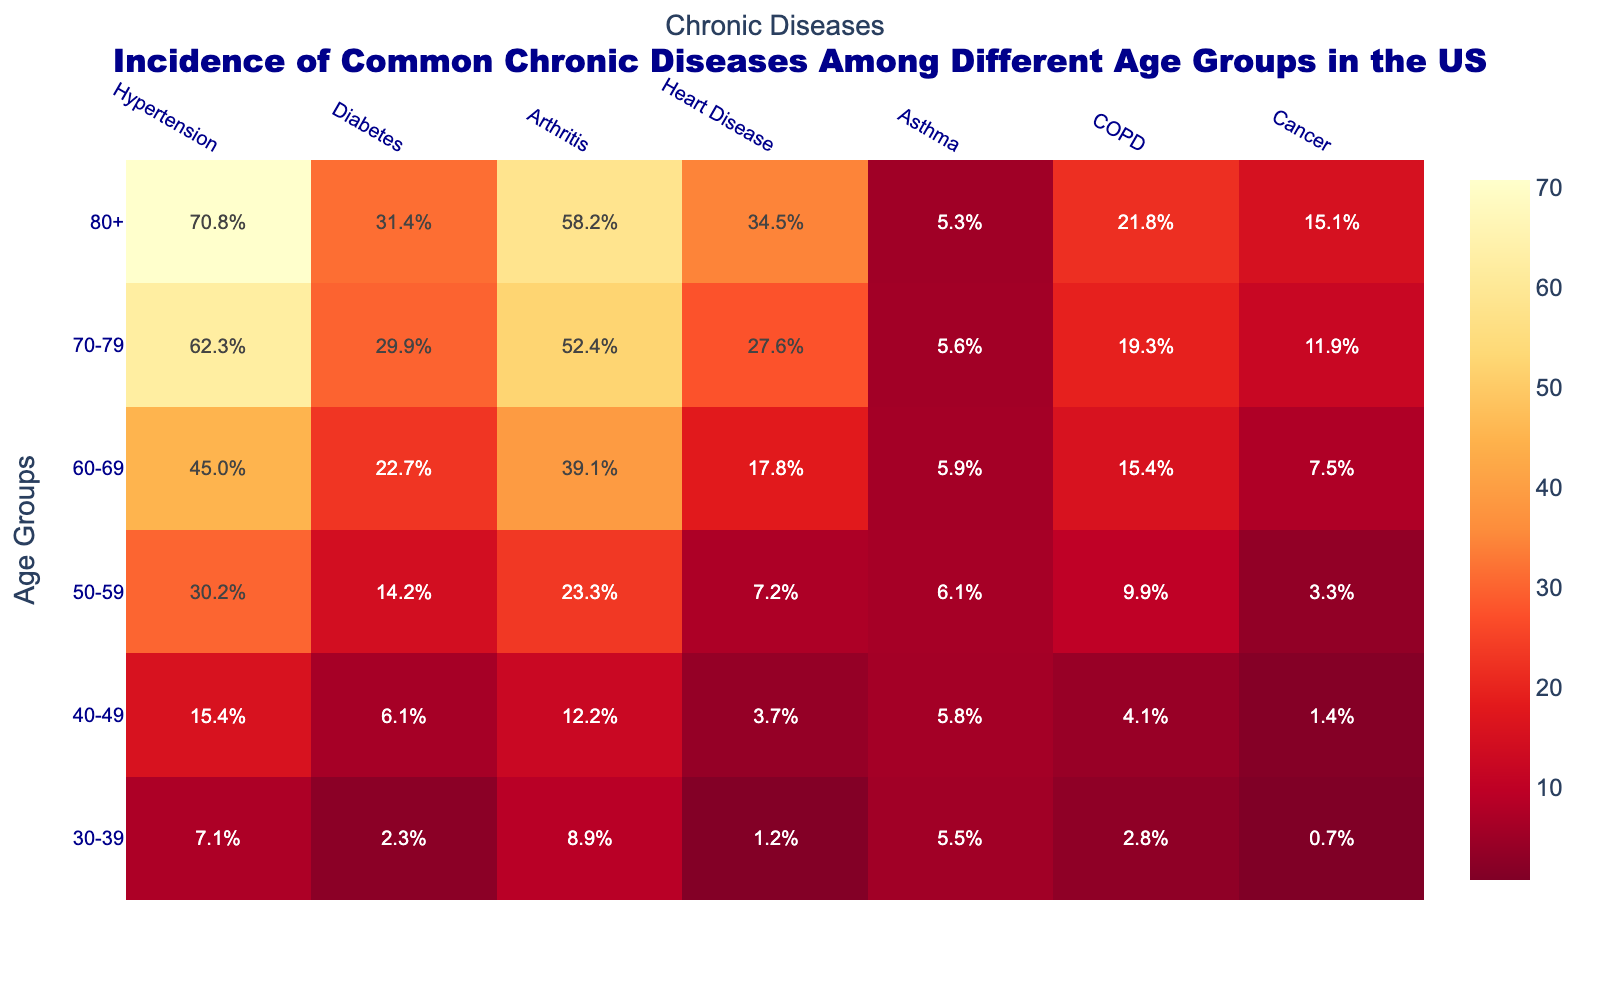What's the title of the figure? The title is prominently displayed at the top center of the figure. It reads: "Incidence of Common Chronic Diseases Among Different Age Groups in the US".
Answer: Incidence of Common Chronic Diseases Among Different Age Groups in the US Which age group has the highest incidence of cancer? Looking at the row corresponding to "Cancer," the highest value is found at the intersection with the age group "80+". This can be quickly identified by the color intensity.
Answer: 80+ What is the average incidence of diabetes across all age groups? The incidence values for diabetes across age groups are 2.3, 6.1, 14.2, 22.7, 29.9, and 31.4. Adding these gives 106.6. Dividing by 6 age groups, the average is calculated as 106.6 / 6.
Answer: 17.8% Comparing asthma and COPD, which disease has the highest incidence in the 70-79 age group? For the age group 70-79, checking the intersections with Asthma and COPD, the values are 5.6 for Asthma and 19.3 for COPD. Since 19.3 is greater than 5.6, COPD has the highest incidence.
Answer: COPD Which chronic disease shows a consistent increase in incidence as age increases? By scanning each column, we observe that the incidence of Hypertension, Diabetes, and Cancer consistently increases with each age group, but Hypertension shows the most consistent increase.
Answer: Hypertension How many age groups have an arthritis incidence rate above 50%? Reviewing the column for Arthritis, the incidence rates above 50% are found in the age groups 70-79 and 80+, giving a count of 2 age groups.
Answer: 2 What's the difference in the incidence of heart disease between the age groups 60-69 and 40-49? The incidence rates for heart disease for these groups are 17.8 (60-69) and 3.7 (40-49). The difference is calculated as 17.8 - 3.7.
Answer: 14.1% Which age group shows the lowest incidence of asthma, and what is the incidence rate? Checking the column for Asthma, the lowest incidence is found at the intersection with the age group "80+", with a rate of 5.3.
Answer: 80+, 5.3% Are there any diseases whose incidence decreases with increasing age? By scanning columns, we see that the incidence of Asthma decreases with increasing age, showing the highest in younger age groups and lowest in older age groups.
Answer: Asthma What is the total incidence percent of chronic diseases for the age group 50-59? For the age group 50-59, sum the values: 30.2 (Hypertension) + 14.2 (Diabetes) + 23.3 (Arthritis) + 7.2 (Heart Disease) + 6.1 (Asthma) + 9.9 (COPD) + 3.3 (Cancer). The total is 94.2.
Answer: 94.2% 